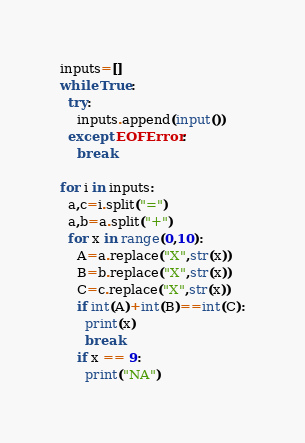Convert code to text. <code><loc_0><loc_0><loc_500><loc_500><_Python_>inputs=[]
while True:
  try:
    inputs.append(input())
  except EOFError:
    break

for i in inputs:
  a,c=i.split("=")
  a,b=a.split("+")
  for x in range(0,10):
    A=a.replace("X",str(x))
    B=b.replace("X",str(x))
    C=c.replace("X",str(x))
    if int(A)+int(B)==int(C):
      print(x)
      break
    if x == 9:
      print("NA")</code> 